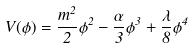Convert formula to latex. <formula><loc_0><loc_0><loc_500><loc_500>V ( \phi ) = \frac { m ^ { 2 } } { 2 } \phi ^ { 2 } - \frac { \alpha } { 3 } \phi ^ { 3 } + \frac { \lambda } { 8 } \phi ^ { 4 }</formula> 